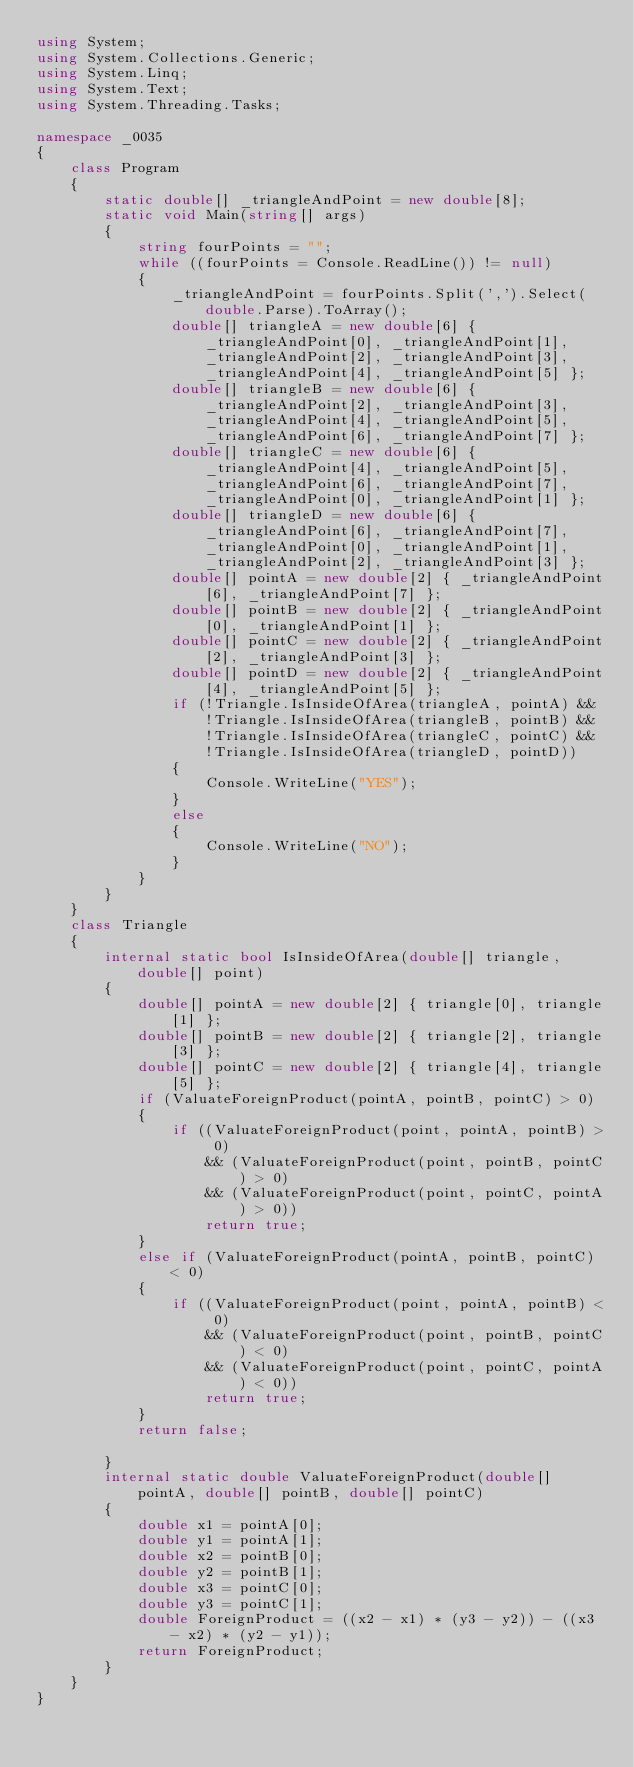Convert code to text. <code><loc_0><loc_0><loc_500><loc_500><_C#_>using System;
using System.Collections.Generic;
using System.Linq;
using System.Text;
using System.Threading.Tasks;

namespace _0035
{
    class Program
    {
        static double[] _triangleAndPoint = new double[8];
        static void Main(string[] args)
        {
            string fourPoints = "";
            while ((fourPoints = Console.ReadLine()) != null)
            {
                _triangleAndPoint = fourPoints.Split(',').Select(double.Parse).ToArray();
                double[] triangleA = new double[6] { _triangleAndPoint[0], _triangleAndPoint[1], _triangleAndPoint[2], _triangleAndPoint[3], _triangleAndPoint[4], _triangleAndPoint[5] };
                double[] triangleB = new double[6] { _triangleAndPoint[2], _triangleAndPoint[3], _triangleAndPoint[4], _triangleAndPoint[5], _triangleAndPoint[6], _triangleAndPoint[7] };
                double[] triangleC = new double[6] { _triangleAndPoint[4], _triangleAndPoint[5], _triangleAndPoint[6], _triangleAndPoint[7], _triangleAndPoint[0], _triangleAndPoint[1] };
                double[] triangleD = new double[6] { _triangleAndPoint[6], _triangleAndPoint[7], _triangleAndPoint[0], _triangleAndPoint[1], _triangleAndPoint[2], _triangleAndPoint[3] };
                double[] pointA = new double[2] { _triangleAndPoint[6], _triangleAndPoint[7] };
                double[] pointB = new double[2] { _triangleAndPoint[0], _triangleAndPoint[1] };
                double[] pointC = new double[2] { _triangleAndPoint[2], _triangleAndPoint[3] };
                double[] pointD = new double[2] { _triangleAndPoint[4], _triangleAndPoint[5] };
                if (!Triangle.IsInsideOfArea(triangleA, pointA) && !Triangle.IsInsideOfArea(triangleB, pointB) && !Triangle.IsInsideOfArea(triangleC, pointC) && !Triangle.IsInsideOfArea(triangleD, pointD))
                {
                    Console.WriteLine("YES");
                }
                else
                {
                    Console.WriteLine("NO");
                }
            }
        }
    }
    class Triangle
    {
        internal static bool IsInsideOfArea(double[] triangle, double[] point)
        {
            double[] pointA = new double[2] { triangle[0], triangle[1] };
            double[] pointB = new double[2] { triangle[2], triangle[3] };
            double[] pointC = new double[2] { triangle[4], triangle[5] };
            if (ValuateForeignProduct(pointA, pointB, pointC) > 0)
            {
                if ((ValuateForeignProduct(point, pointA, pointB) > 0)
                    && (ValuateForeignProduct(point, pointB, pointC) > 0)
                    && (ValuateForeignProduct(point, pointC, pointA) > 0))
                    return true;
            }
            else if (ValuateForeignProduct(pointA, pointB, pointC) < 0)
            {
                if ((ValuateForeignProduct(point, pointA, pointB) < 0)
                    && (ValuateForeignProduct(point, pointB, pointC) < 0)
                    && (ValuateForeignProduct(point, pointC, pointA) < 0))
                    return true;
            }
            return false;

        }
        internal static double ValuateForeignProduct(double[] pointA, double[] pointB, double[] pointC)
        {
            double x1 = pointA[0];
            double y1 = pointA[1];
            double x2 = pointB[0];
            double y2 = pointB[1];
            double x3 = pointC[0];
            double y3 = pointC[1];
            double ForeignProduct = ((x2 - x1) * (y3 - y2)) - ((x3 - x2) * (y2 - y1));
            return ForeignProduct;
        }
    }
}


</code> 